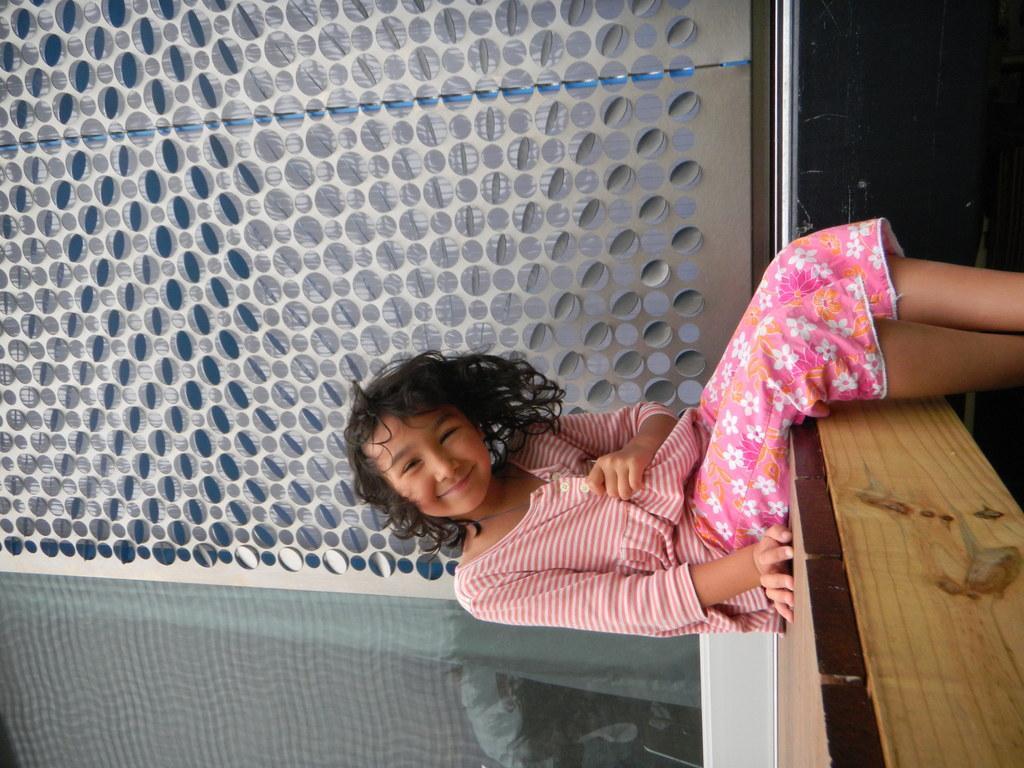How would you summarize this image in a sentence or two? In this image a girl is sitting on the wooden furniture. She is wearing pink top. Behind her there is a wall having few design on it. 